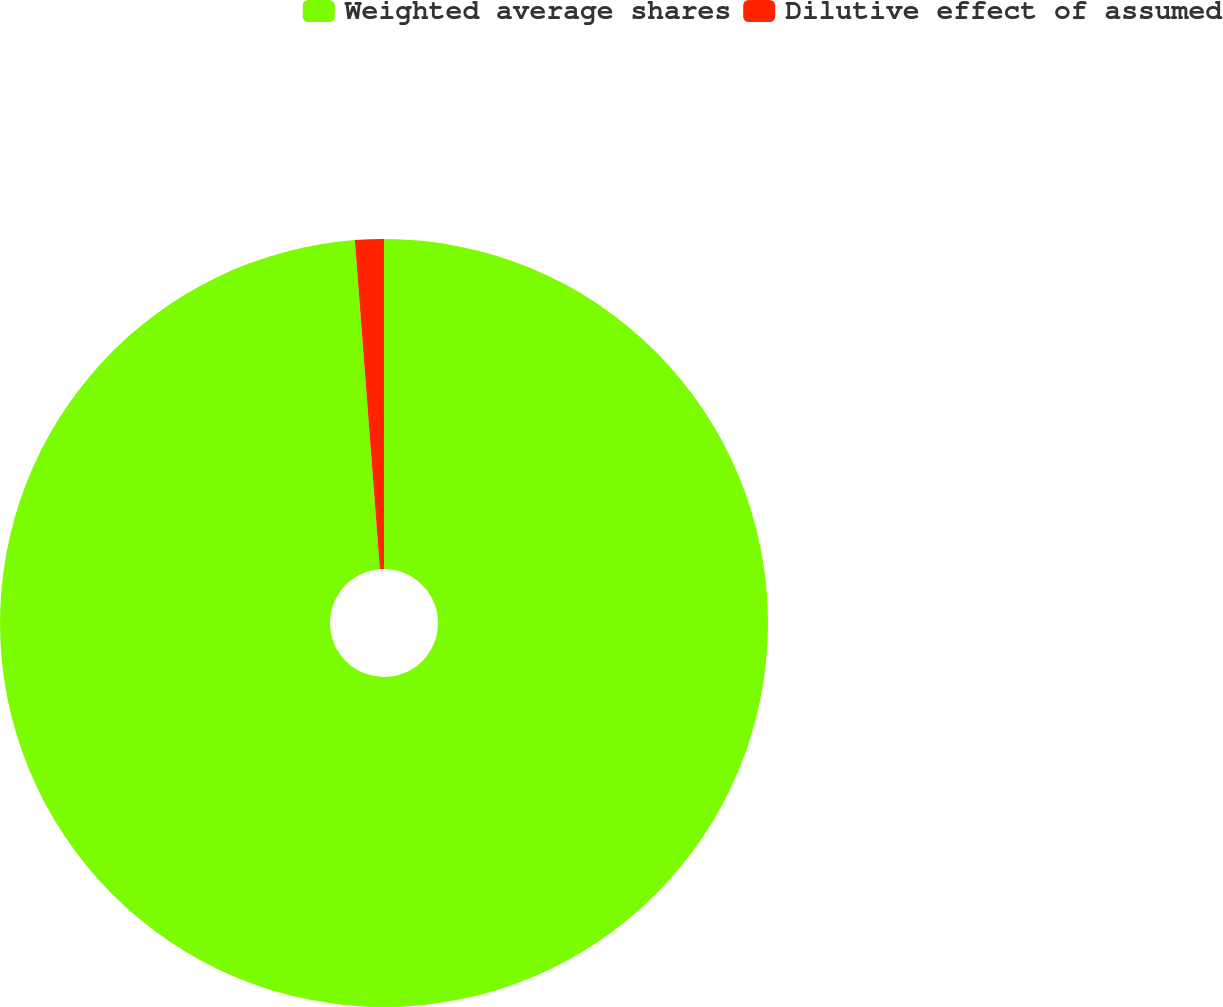Convert chart to OTSL. <chart><loc_0><loc_0><loc_500><loc_500><pie_chart><fcel>Weighted average shares<fcel>Dilutive effect of assumed<nl><fcel>98.79%<fcel>1.21%<nl></chart> 